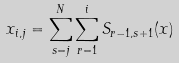Convert formula to latex. <formula><loc_0><loc_0><loc_500><loc_500>x _ { i , j } = \sum _ { s = j } ^ { N } \sum _ { r = 1 } ^ { i } S _ { r - 1 , s + 1 } ( x )</formula> 